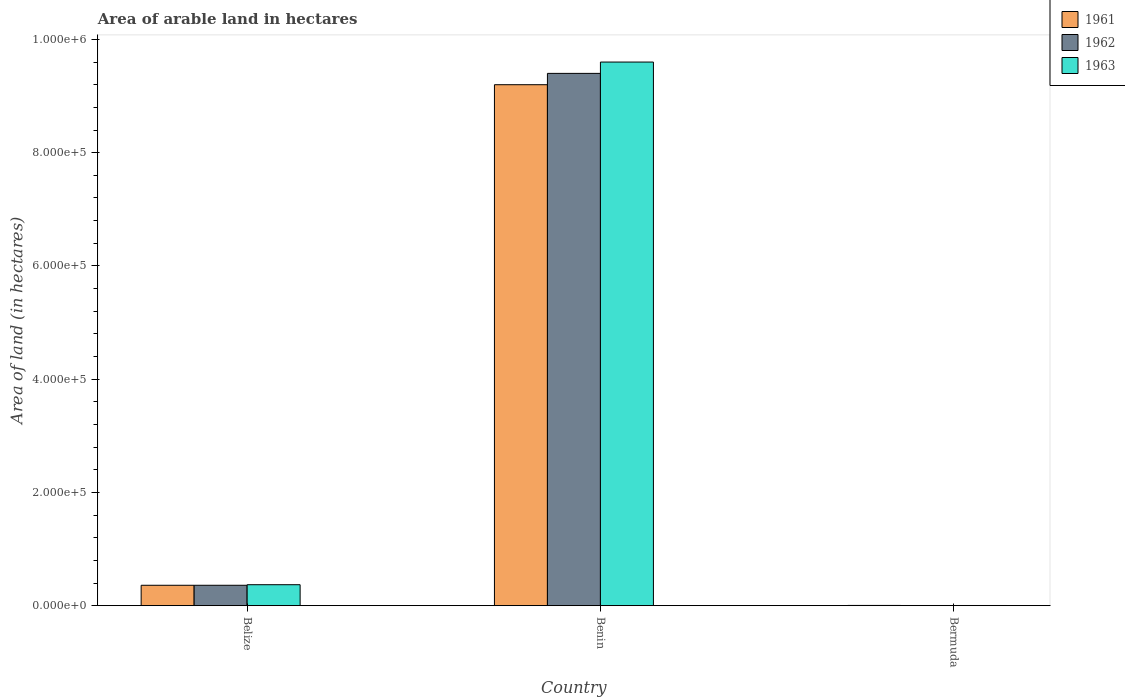Are the number of bars per tick equal to the number of legend labels?
Offer a very short reply. Yes. Are the number of bars on each tick of the X-axis equal?
Your answer should be compact. Yes. What is the label of the 1st group of bars from the left?
Your answer should be very brief. Belize. What is the total arable land in 1963 in Benin?
Provide a short and direct response. 9.60e+05. Across all countries, what is the maximum total arable land in 1963?
Keep it short and to the point. 9.60e+05. Across all countries, what is the minimum total arable land in 1961?
Provide a succinct answer. 400. In which country was the total arable land in 1962 maximum?
Provide a succinct answer. Benin. In which country was the total arable land in 1962 minimum?
Offer a very short reply. Bermuda. What is the total total arable land in 1963 in the graph?
Your answer should be very brief. 9.97e+05. What is the difference between the total arable land in 1962 in Belize and that in Bermuda?
Offer a terse response. 3.57e+04. What is the difference between the total arable land in 1963 in Belize and the total arable land in 1962 in Bermuda?
Offer a very short reply. 3.67e+04. What is the average total arable land in 1963 per country?
Your response must be concise. 3.32e+05. What is the difference between the total arable land of/in 1962 and total arable land of/in 1961 in Belize?
Provide a succinct answer. 0. In how many countries, is the total arable land in 1963 greater than 320000 hectares?
Make the answer very short. 1. What is the ratio of the total arable land in 1963 in Belize to that in Benin?
Make the answer very short. 0.04. Is the total arable land in 1961 in Belize less than that in Bermuda?
Your answer should be compact. No. Is the difference between the total arable land in 1962 in Benin and Bermuda greater than the difference between the total arable land in 1961 in Benin and Bermuda?
Keep it short and to the point. Yes. What is the difference between the highest and the second highest total arable land in 1962?
Your response must be concise. 9.40e+05. What is the difference between the highest and the lowest total arable land in 1962?
Offer a very short reply. 9.40e+05. In how many countries, is the total arable land in 1963 greater than the average total arable land in 1963 taken over all countries?
Offer a terse response. 1. Is the sum of the total arable land in 1961 in Belize and Benin greater than the maximum total arable land in 1962 across all countries?
Provide a succinct answer. Yes. What does the 3rd bar from the left in Belize represents?
Your answer should be very brief. 1963. Is it the case that in every country, the sum of the total arable land in 1962 and total arable land in 1963 is greater than the total arable land in 1961?
Offer a terse response. Yes. How many bars are there?
Give a very brief answer. 9. Are all the bars in the graph horizontal?
Provide a succinct answer. No. Are the values on the major ticks of Y-axis written in scientific E-notation?
Offer a terse response. Yes. Where does the legend appear in the graph?
Give a very brief answer. Top right. What is the title of the graph?
Ensure brevity in your answer.  Area of arable land in hectares. What is the label or title of the Y-axis?
Offer a very short reply. Area of land (in hectares). What is the Area of land (in hectares) in 1961 in Belize?
Offer a very short reply. 3.60e+04. What is the Area of land (in hectares) of 1962 in Belize?
Your response must be concise. 3.60e+04. What is the Area of land (in hectares) of 1963 in Belize?
Provide a succinct answer. 3.70e+04. What is the Area of land (in hectares) of 1961 in Benin?
Provide a short and direct response. 9.20e+05. What is the Area of land (in hectares) in 1962 in Benin?
Ensure brevity in your answer.  9.40e+05. What is the Area of land (in hectares) of 1963 in Benin?
Provide a succinct answer. 9.60e+05. What is the Area of land (in hectares) of 1962 in Bermuda?
Offer a terse response. 300. What is the Area of land (in hectares) of 1963 in Bermuda?
Make the answer very short. 300. Across all countries, what is the maximum Area of land (in hectares) in 1961?
Offer a very short reply. 9.20e+05. Across all countries, what is the maximum Area of land (in hectares) of 1962?
Ensure brevity in your answer.  9.40e+05. Across all countries, what is the maximum Area of land (in hectares) in 1963?
Your answer should be compact. 9.60e+05. Across all countries, what is the minimum Area of land (in hectares) in 1962?
Offer a terse response. 300. Across all countries, what is the minimum Area of land (in hectares) in 1963?
Your answer should be compact. 300. What is the total Area of land (in hectares) of 1961 in the graph?
Your response must be concise. 9.56e+05. What is the total Area of land (in hectares) in 1962 in the graph?
Provide a short and direct response. 9.76e+05. What is the total Area of land (in hectares) in 1963 in the graph?
Your response must be concise. 9.97e+05. What is the difference between the Area of land (in hectares) of 1961 in Belize and that in Benin?
Make the answer very short. -8.84e+05. What is the difference between the Area of land (in hectares) in 1962 in Belize and that in Benin?
Your answer should be compact. -9.04e+05. What is the difference between the Area of land (in hectares) of 1963 in Belize and that in Benin?
Provide a short and direct response. -9.23e+05. What is the difference between the Area of land (in hectares) in 1961 in Belize and that in Bermuda?
Provide a succinct answer. 3.56e+04. What is the difference between the Area of land (in hectares) of 1962 in Belize and that in Bermuda?
Offer a very short reply. 3.57e+04. What is the difference between the Area of land (in hectares) in 1963 in Belize and that in Bermuda?
Offer a very short reply. 3.67e+04. What is the difference between the Area of land (in hectares) in 1961 in Benin and that in Bermuda?
Give a very brief answer. 9.20e+05. What is the difference between the Area of land (in hectares) of 1962 in Benin and that in Bermuda?
Keep it short and to the point. 9.40e+05. What is the difference between the Area of land (in hectares) in 1963 in Benin and that in Bermuda?
Provide a short and direct response. 9.60e+05. What is the difference between the Area of land (in hectares) of 1961 in Belize and the Area of land (in hectares) of 1962 in Benin?
Offer a very short reply. -9.04e+05. What is the difference between the Area of land (in hectares) in 1961 in Belize and the Area of land (in hectares) in 1963 in Benin?
Your answer should be very brief. -9.24e+05. What is the difference between the Area of land (in hectares) in 1962 in Belize and the Area of land (in hectares) in 1963 in Benin?
Keep it short and to the point. -9.24e+05. What is the difference between the Area of land (in hectares) of 1961 in Belize and the Area of land (in hectares) of 1962 in Bermuda?
Give a very brief answer. 3.57e+04. What is the difference between the Area of land (in hectares) in 1961 in Belize and the Area of land (in hectares) in 1963 in Bermuda?
Provide a succinct answer. 3.57e+04. What is the difference between the Area of land (in hectares) of 1962 in Belize and the Area of land (in hectares) of 1963 in Bermuda?
Ensure brevity in your answer.  3.57e+04. What is the difference between the Area of land (in hectares) of 1961 in Benin and the Area of land (in hectares) of 1962 in Bermuda?
Give a very brief answer. 9.20e+05. What is the difference between the Area of land (in hectares) in 1961 in Benin and the Area of land (in hectares) in 1963 in Bermuda?
Keep it short and to the point. 9.20e+05. What is the difference between the Area of land (in hectares) in 1962 in Benin and the Area of land (in hectares) in 1963 in Bermuda?
Keep it short and to the point. 9.40e+05. What is the average Area of land (in hectares) in 1961 per country?
Provide a short and direct response. 3.19e+05. What is the average Area of land (in hectares) in 1962 per country?
Offer a very short reply. 3.25e+05. What is the average Area of land (in hectares) of 1963 per country?
Provide a succinct answer. 3.32e+05. What is the difference between the Area of land (in hectares) of 1961 and Area of land (in hectares) of 1963 in Belize?
Offer a very short reply. -1000. What is the difference between the Area of land (in hectares) of 1962 and Area of land (in hectares) of 1963 in Belize?
Offer a very short reply. -1000. What is the difference between the Area of land (in hectares) of 1961 and Area of land (in hectares) of 1962 in Benin?
Your response must be concise. -2.00e+04. What is the difference between the Area of land (in hectares) of 1961 and Area of land (in hectares) of 1962 in Bermuda?
Ensure brevity in your answer.  100. What is the difference between the Area of land (in hectares) of 1961 and Area of land (in hectares) of 1963 in Bermuda?
Give a very brief answer. 100. What is the ratio of the Area of land (in hectares) in 1961 in Belize to that in Benin?
Offer a terse response. 0.04. What is the ratio of the Area of land (in hectares) of 1962 in Belize to that in Benin?
Give a very brief answer. 0.04. What is the ratio of the Area of land (in hectares) of 1963 in Belize to that in Benin?
Provide a succinct answer. 0.04. What is the ratio of the Area of land (in hectares) in 1961 in Belize to that in Bermuda?
Your answer should be compact. 90. What is the ratio of the Area of land (in hectares) of 1962 in Belize to that in Bermuda?
Give a very brief answer. 120. What is the ratio of the Area of land (in hectares) in 1963 in Belize to that in Bermuda?
Offer a terse response. 123.33. What is the ratio of the Area of land (in hectares) in 1961 in Benin to that in Bermuda?
Give a very brief answer. 2300. What is the ratio of the Area of land (in hectares) of 1962 in Benin to that in Bermuda?
Offer a very short reply. 3133.33. What is the ratio of the Area of land (in hectares) of 1963 in Benin to that in Bermuda?
Offer a very short reply. 3200. What is the difference between the highest and the second highest Area of land (in hectares) of 1961?
Offer a very short reply. 8.84e+05. What is the difference between the highest and the second highest Area of land (in hectares) of 1962?
Your response must be concise. 9.04e+05. What is the difference between the highest and the second highest Area of land (in hectares) of 1963?
Your response must be concise. 9.23e+05. What is the difference between the highest and the lowest Area of land (in hectares) of 1961?
Give a very brief answer. 9.20e+05. What is the difference between the highest and the lowest Area of land (in hectares) in 1962?
Your response must be concise. 9.40e+05. What is the difference between the highest and the lowest Area of land (in hectares) of 1963?
Make the answer very short. 9.60e+05. 